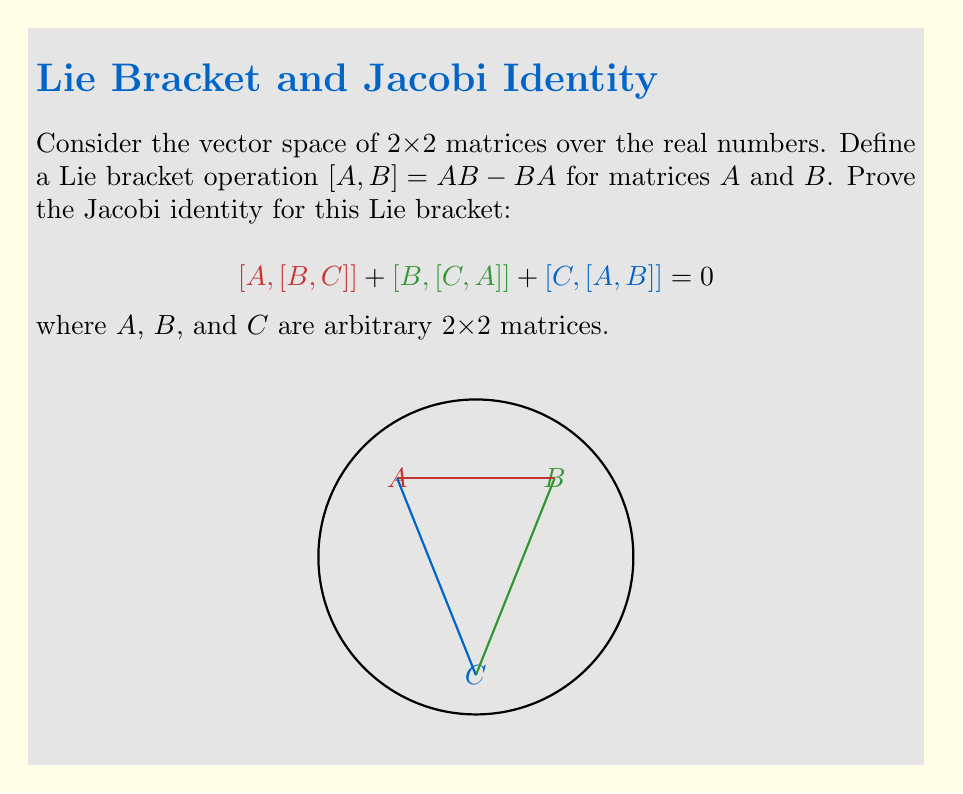What is the answer to this math problem? Let's prove the Jacobi identity step by step:

1) First, let's expand $[A,[B,C]]$:
   $$[A,[B,C]] = A(BC-CB) - (BC-CB)A$$

2) Expanding further:
   $$[A,[B,C]] = ABC - ACB - BCA + CBA$$

3) Similarly, let's expand $[B,[C,A]]$ and $[C,[A,B]]$:
   $$[B,[C,A]] = BCA - BAC - CAB + ABC$$
   $$[C,[A,B]] = CAB - CBA - ACB + BCA$$

4) Now, let's add all three terms:
   $$[A,[B,C]] + [B,[C,A]] + [C,[A,B]] = $$
   $$(ABC - ACB - BCA + CBA) + (BCA - BAC - CAB + ABC) + (CAB - CBA - ACB + BCA)$$

5) Observe that each term appears twice with opposite signs:
   - ABC appears in $[A,[B,C]]$ and $[B,[C,A]]$
   - BCA appears in $[B,[C,A]]$ and $[C,[A,B]]$
   - CAB appears in $[C,[A,B]]$ and $[B,[C,A]]$
   - ACB appears in $[A,[B,C]]$ and $[C,[A,B]]$
   - BAC appears only in $[B,[C,A]]$
   - CBA appears in $[A,[B,C]]$ and $[C,[A,B]]$

6) When we sum all these terms, they cancel out completely:
   $$ABC - ABC + BCA - BCA + CAB - CAB - ACB + ACB - BAC + BAC + CBA - CBA = 0$$

Thus, we have proven that $[A,[B,C]] + [B,[C,A]] + [C,[A,B]] = 0$ for any 2x2 matrices $A$, $B$, and $C$, which is the Jacobi identity for this Lie bracket.
Answer: The Jacobi identity holds as all terms cancel out when expanded and summed. 